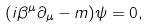Convert formula to latex. <formula><loc_0><loc_0><loc_500><loc_500>( i \beta ^ { \mu } \partial _ { \mu } - m ) \psi = 0 ,</formula> 